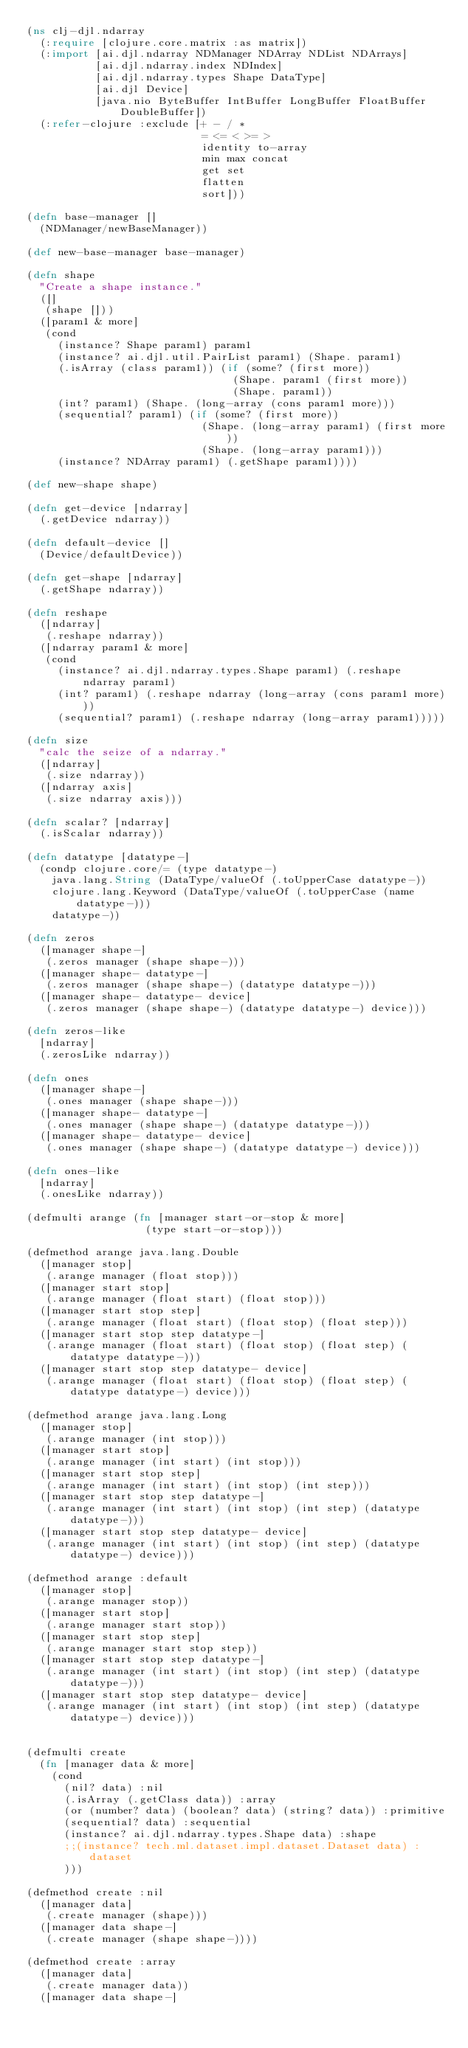<code> <loc_0><loc_0><loc_500><loc_500><_Clojure_>(ns clj-djl.ndarray
  (:require [clojure.core.matrix :as matrix])
  (:import [ai.djl.ndarray NDManager NDArray NDList NDArrays]
           [ai.djl.ndarray.index NDIndex]
           [ai.djl.ndarray.types Shape DataType]
           [ai.djl Device]
           [java.nio ByteBuffer IntBuffer LongBuffer FloatBuffer DoubleBuffer])
  (:refer-clojure :exclude [+ - / *
                            = <= < >= >
                            identity to-array
                            min max concat
                            get set
                            flatten
                            sort]))

(defn base-manager []
  (NDManager/newBaseManager))

(def new-base-manager base-manager)

(defn shape
  "Create a shape instance."
  ([]
   (shape []))
  ([param1 & more]
   (cond
     (instance? Shape param1) param1
     (instance? ai.djl.util.PairList param1) (Shape. param1)
     (.isArray (class param1)) (if (some? (first more))
                                 (Shape. param1 (first more))
                                 (Shape. param1))
     (int? param1) (Shape. (long-array (cons param1 more)))
     (sequential? param1) (if (some? (first more))
                            (Shape. (long-array param1) (first more))
                            (Shape. (long-array param1)))
     (instance? NDArray param1) (.getShape param1))))

(def new-shape shape)

(defn get-device [ndarray]
  (.getDevice ndarray))

(defn default-device []
  (Device/defaultDevice))

(defn get-shape [ndarray]
  (.getShape ndarray))

(defn reshape
  ([ndarray]
   (.reshape ndarray))
  ([ndarray param1 & more]
   (cond
     (instance? ai.djl.ndarray.types.Shape param1) (.reshape ndarray param1)
     (int? param1) (.reshape ndarray (long-array (cons param1 more)))
     (sequential? param1) (.reshape ndarray (long-array param1)))))

(defn size
  "calc the seize of a ndarray."
  ([ndarray]
   (.size ndarray))
  ([ndarray axis]
   (.size ndarray axis)))

(defn scalar? [ndarray]
  (.isScalar ndarray))

(defn datatype [datatype-]
  (condp clojure.core/= (type datatype-)
    java.lang.String (DataType/valueOf (.toUpperCase datatype-))
    clojure.lang.Keyword (DataType/valueOf (.toUpperCase (name datatype-)))
    datatype-))

(defn zeros
  ([manager shape-]
   (.zeros manager (shape shape-)))
  ([manager shape- datatype-]
   (.zeros manager (shape shape-) (datatype datatype-)))
  ([manager shape- datatype- device]
   (.zeros manager (shape shape-) (datatype datatype-) device)))

(defn zeros-like
  [ndarray]
  (.zerosLike ndarray))

(defn ones
  ([manager shape-]
   (.ones manager (shape shape-)))
  ([manager shape- datatype-]
   (.ones manager (shape shape-) (datatype datatype-)))
  ([manager shape- datatype- device]
   (.ones manager (shape shape-) (datatype datatype-) device)))

(defn ones-like
  [ndarray]
  (.onesLike ndarray))

(defmulti arange (fn [manager start-or-stop & more]
                   (type start-or-stop)))

(defmethod arange java.lang.Double
  ([manager stop]
   (.arange manager (float stop)))
  ([manager start stop]
   (.arange manager (float start) (float stop)))
  ([manager start stop step]
   (.arange manager (float start) (float stop) (float step)))
  ([manager start stop step datatype-]
   (.arange manager (float start) (float stop) (float step) (datatype datatype-)))
  ([manager start stop step datatype- device]
   (.arange manager (float start) (float stop) (float step) (datatype datatype-) device)))

(defmethod arange java.lang.Long
  ([manager stop]
   (.arange manager (int stop)))
  ([manager start stop]
   (.arange manager (int start) (int stop)))
  ([manager start stop step]
   (.arange manager (int start) (int stop) (int step)))
  ([manager start stop step datatype-]
   (.arange manager (int start) (int stop) (int step) (datatype datatype-)))
  ([manager start stop step datatype- device]
   (.arange manager (int start) (int stop) (int step) (datatype datatype-) device)))

(defmethod arange :default
  ([manager stop]
   (.arange manager stop))
  ([manager start stop]
   (.arange manager start stop))
  ([manager start stop step]
   (.arange manager start stop step))
  ([manager start stop step datatype-]
   (.arange manager (int start) (int stop) (int step) (datatype datatype-)))
  ([manager start stop step datatype- device]
   (.arange manager (int start) (int stop) (int step) (datatype datatype-) device)))


(defmulti create
  (fn [manager data & more]
    (cond
      (nil? data) :nil
      (.isArray (.getClass data)) :array
      (or (number? data) (boolean? data) (string? data)) :primitive
      (sequential? data) :sequential
      (instance? ai.djl.ndarray.types.Shape data) :shape
      ;;(instance? tech.ml.dataset.impl.dataset.Dataset data) :dataset
      )))

(defmethod create :nil
  ([manager data]
   (.create manager (shape)))
  ([manager data shape-]
   (.create manager (shape shape-))))

(defmethod create :array
  ([manager data]
   (.create manager data))
  ([manager data shape-]</code> 